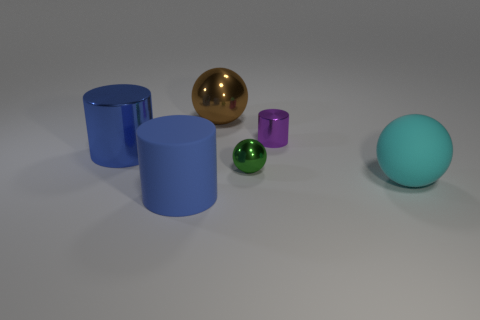Subtract all large blue cylinders. How many cylinders are left? 1 Subtract all cyan balls. How many balls are left? 2 Subtract 1 spheres. How many spheres are left? 2 Add 1 small gray rubber things. How many objects exist? 7 Subtract 1 cyan balls. How many objects are left? 5 Subtract all brown spheres. Subtract all green blocks. How many spheres are left? 2 Subtract all yellow cubes. How many blue cylinders are left? 2 Subtract all tiny purple objects. Subtract all small green balls. How many objects are left? 4 Add 1 small purple cylinders. How many small purple cylinders are left? 2 Add 5 brown things. How many brown things exist? 6 